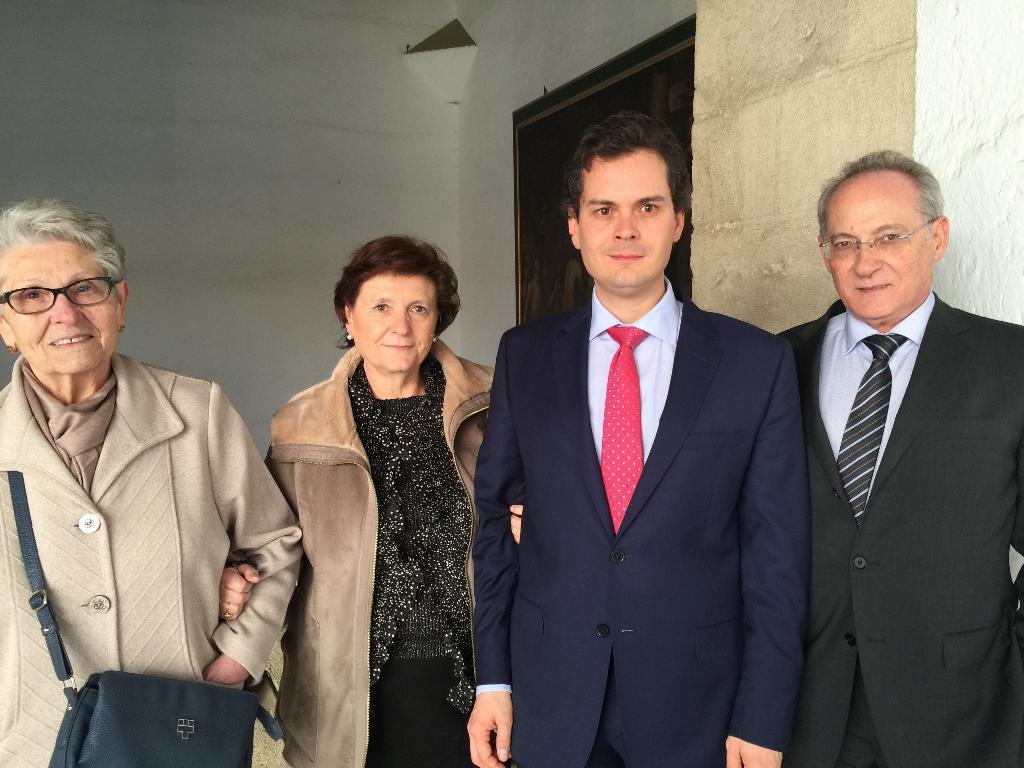Please provide a concise description of this image. In this image I can see a group of people. In the background, I can see the wall. 